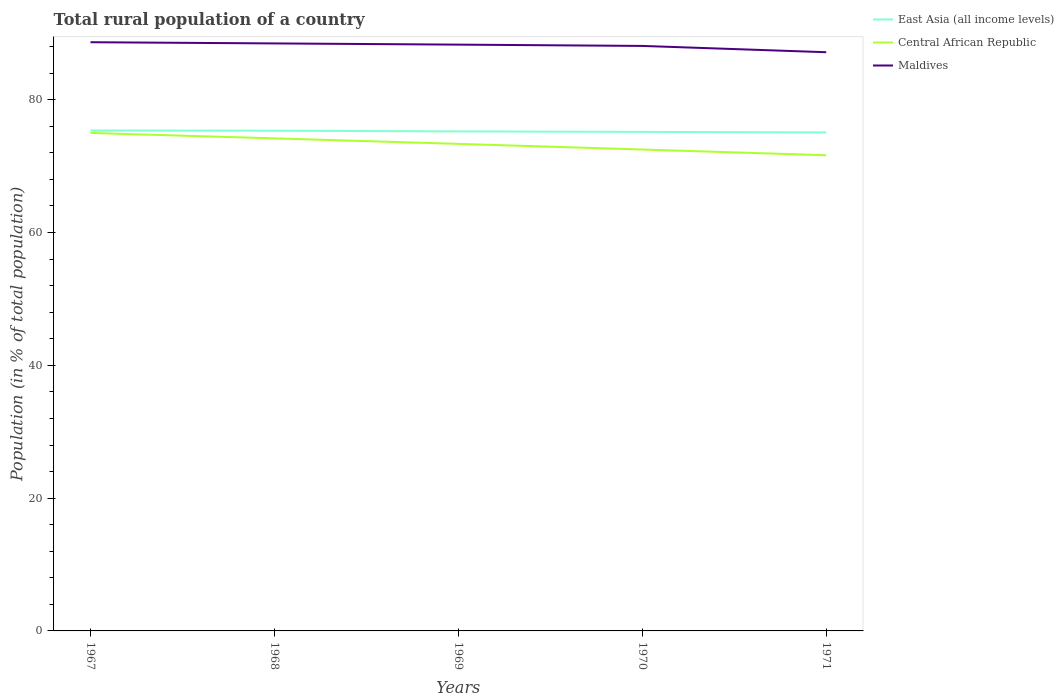How many different coloured lines are there?
Provide a short and direct response. 3. Does the line corresponding to Central African Republic intersect with the line corresponding to East Asia (all income levels)?
Your response must be concise. No. Is the number of lines equal to the number of legend labels?
Your answer should be very brief. Yes. Across all years, what is the maximum rural population in Maldives?
Give a very brief answer. 87.16. In which year was the rural population in Maldives maximum?
Provide a short and direct response. 1971. What is the total rural population in Maldives in the graph?
Keep it short and to the point. 1.51. What is the difference between the highest and the second highest rural population in Maldives?
Your answer should be very brief. 1.51. Is the rural population in East Asia (all income levels) strictly greater than the rural population in Maldives over the years?
Your response must be concise. Yes. How many years are there in the graph?
Keep it short and to the point. 5. What is the difference between two consecutive major ticks on the Y-axis?
Give a very brief answer. 20. Are the values on the major ticks of Y-axis written in scientific E-notation?
Offer a terse response. No. Does the graph contain grids?
Keep it short and to the point. No. What is the title of the graph?
Your response must be concise. Total rural population of a country. Does "Cabo Verde" appear as one of the legend labels in the graph?
Your answer should be compact. No. What is the label or title of the X-axis?
Offer a terse response. Years. What is the label or title of the Y-axis?
Make the answer very short. Population (in % of total population). What is the Population (in % of total population) in East Asia (all income levels) in 1967?
Give a very brief answer. 75.37. What is the Population (in % of total population) in Maldives in 1967?
Your answer should be very brief. 88.66. What is the Population (in % of total population) in East Asia (all income levels) in 1968?
Provide a short and direct response. 75.34. What is the Population (in % of total population) in Central African Republic in 1968?
Your answer should be compact. 74.19. What is the Population (in % of total population) in Maldives in 1968?
Provide a succinct answer. 88.48. What is the Population (in % of total population) in East Asia (all income levels) in 1969?
Give a very brief answer. 75.23. What is the Population (in % of total population) in Central African Republic in 1969?
Your answer should be very brief. 73.36. What is the Population (in % of total population) of Maldives in 1969?
Your answer should be very brief. 88.3. What is the Population (in % of total population) in East Asia (all income levels) in 1970?
Offer a very short reply. 75.16. What is the Population (in % of total population) in Central African Republic in 1970?
Provide a succinct answer. 72.51. What is the Population (in % of total population) of Maldives in 1970?
Provide a succinct answer. 88.11. What is the Population (in % of total population) of East Asia (all income levels) in 1971?
Offer a very short reply. 75.08. What is the Population (in % of total population) in Central African Republic in 1971?
Keep it short and to the point. 71.64. What is the Population (in % of total population) of Maldives in 1971?
Offer a very short reply. 87.16. Across all years, what is the maximum Population (in % of total population) in East Asia (all income levels)?
Give a very brief answer. 75.37. Across all years, what is the maximum Population (in % of total population) of Maldives?
Provide a short and direct response. 88.66. Across all years, what is the minimum Population (in % of total population) in East Asia (all income levels)?
Give a very brief answer. 75.08. Across all years, what is the minimum Population (in % of total population) in Central African Republic?
Give a very brief answer. 71.64. Across all years, what is the minimum Population (in % of total population) in Maldives?
Your answer should be compact. 87.16. What is the total Population (in % of total population) in East Asia (all income levels) in the graph?
Your answer should be compact. 376.18. What is the total Population (in % of total population) in Central African Republic in the graph?
Provide a short and direct response. 366.69. What is the total Population (in % of total population) in Maldives in the graph?
Provide a succinct answer. 440.71. What is the difference between the Population (in % of total population) in East Asia (all income levels) in 1967 and that in 1968?
Provide a succinct answer. 0.04. What is the difference between the Population (in % of total population) in Central African Republic in 1967 and that in 1968?
Your answer should be very brief. 0.81. What is the difference between the Population (in % of total population) in Maldives in 1967 and that in 1968?
Keep it short and to the point. 0.18. What is the difference between the Population (in % of total population) in East Asia (all income levels) in 1967 and that in 1969?
Keep it short and to the point. 0.14. What is the difference between the Population (in % of total population) in Central African Republic in 1967 and that in 1969?
Give a very brief answer. 1.65. What is the difference between the Population (in % of total population) in Maldives in 1967 and that in 1969?
Provide a succinct answer. 0.36. What is the difference between the Population (in % of total population) of East Asia (all income levels) in 1967 and that in 1970?
Provide a short and direct response. 0.21. What is the difference between the Population (in % of total population) of Central African Republic in 1967 and that in 1970?
Your answer should be compact. 2.49. What is the difference between the Population (in % of total population) in Maldives in 1967 and that in 1970?
Your response must be concise. 0.56. What is the difference between the Population (in % of total population) of East Asia (all income levels) in 1967 and that in 1971?
Offer a very short reply. 0.29. What is the difference between the Population (in % of total population) of Central African Republic in 1967 and that in 1971?
Give a very brief answer. 3.36. What is the difference between the Population (in % of total population) in Maldives in 1967 and that in 1971?
Offer a terse response. 1.51. What is the difference between the Population (in % of total population) of East Asia (all income levels) in 1968 and that in 1969?
Ensure brevity in your answer.  0.1. What is the difference between the Population (in % of total population) of Central African Republic in 1968 and that in 1969?
Give a very brief answer. 0.83. What is the difference between the Population (in % of total population) in Maldives in 1968 and that in 1969?
Offer a very short reply. 0.18. What is the difference between the Population (in % of total population) of East Asia (all income levels) in 1968 and that in 1970?
Make the answer very short. 0.18. What is the difference between the Population (in % of total population) of Central African Republic in 1968 and that in 1970?
Keep it short and to the point. 1.68. What is the difference between the Population (in % of total population) of Maldives in 1968 and that in 1970?
Your answer should be very brief. 0.38. What is the difference between the Population (in % of total population) in East Asia (all income levels) in 1968 and that in 1971?
Make the answer very short. 0.26. What is the difference between the Population (in % of total population) of Central African Republic in 1968 and that in 1971?
Ensure brevity in your answer.  2.54. What is the difference between the Population (in % of total population) of Maldives in 1968 and that in 1971?
Give a very brief answer. 1.33. What is the difference between the Population (in % of total population) in East Asia (all income levels) in 1969 and that in 1970?
Your answer should be very brief. 0.07. What is the difference between the Population (in % of total population) of Central African Republic in 1969 and that in 1970?
Offer a terse response. 0.85. What is the difference between the Population (in % of total population) in Maldives in 1969 and that in 1970?
Give a very brief answer. 0.2. What is the difference between the Population (in % of total population) of East Asia (all income levels) in 1969 and that in 1971?
Give a very brief answer. 0.15. What is the difference between the Population (in % of total population) in Central African Republic in 1969 and that in 1971?
Your response must be concise. 1.71. What is the difference between the Population (in % of total population) in Maldives in 1969 and that in 1971?
Make the answer very short. 1.14. What is the difference between the Population (in % of total population) of East Asia (all income levels) in 1970 and that in 1971?
Your response must be concise. 0.08. What is the difference between the Population (in % of total population) in Central African Republic in 1970 and that in 1971?
Give a very brief answer. 0.86. What is the difference between the Population (in % of total population) in Maldives in 1970 and that in 1971?
Your response must be concise. 0.95. What is the difference between the Population (in % of total population) in East Asia (all income levels) in 1967 and the Population (in % of total population) in Central African Republic in 1968?
Your answer should be compact. 1.19. What is the difference between the Population (in % of total population) in East Asia (all income levels) in 1967 and the Population (in % of total population) in Maldives in 1968?
Keep it short and to the point. -13.11. What is the difference between the Population (in % of total population) of Central African Republic in 1967 and the Population (in % of total population) of Maldives in 1968?
Provide a short and direct response. -13.48. What is the difference between the Population (in % of total population) of East Asia (all income levels) in 1967 and the Population (in % of total population) of Central African Republic in 1969?
Provide a short and direct response. 2.02. What is the difference between the Population (in % of total population) in East Asia (all income levels) in 1967 and the Population (in % of total population) in Maldives in 1969?
Ensure brevity in your answer.  -12.93. What is the difference between the Population (in % of total population) of Central African Republic in 1967 and the Population (in % of total population) of Maldives in 1969?
Your answer should be very brief. -13.3. What is the difference between the Population (in % of total population) in East Asia (all income levels) in 1967 and the Population (in % of total population) in Central African Republic in 1970?
Give a very brief answer. 2.87. What is the difference between the Population (in % of total population) in East Asia (all income levels) in 1967 and the Population (in % of total population) in Maldives in 1970?
Keep it short and to the point. -12.73. What is the difference between the Population (in % of total population) in Central African Republic in 1967 and the Population (in % of total population) in Maldives in 1970?
Offer a very short reply. -13.11. What is the difference between the Population (in % of total population) in East Asia (all income levels) in 1967 and the Population (in % of total population) in Central African Republic in 1971?
Your answer should be very brief. 3.73. What is the difference between the Population (in % of total population) in East Asia (all income levels) in 1967 and the Population (in % of total population) in Maldives in 1971?
Your answer should be compact. -11.78. What is the difference between the Population (in % of total population) of Central African Republic in 1967 and the Population (in % of total population) of Maldives in 1971?
Give a very brief answer. -12.16. What is the difference between the Population (in % of total population) in East Asia (all income levels) in 1968 and the Population (in % of total population) in Central African Republic in 1969?
Your answer should be compact. 1.98. What is the difference between the Population (in % of total population) of East Asia (all income levels) in 1968 and the Population (in % of total population) of Maldives in 1969?
Your answer should be very brief. -12.96. What is the difference between the Population (in % of total population) in Central African Republic in 1968 and the Population (in % of total population) in Maldives in 1969?
Your response must be concise. -14.12. What is the difference between the Population (in % of total population) in East Asia (all income levels) in 1968 and the Population (in % of total population) in Central African Republic in 1970?
Offer a terse response. 2.83. What is the difference between the Population (in % of total population) of East Asia (all income levels) in 1968 and the Population (in % of total population) of Maldives in 1970?
Provide a short and direct response. -12.77. What is the difference between the Population (in % of total population) of Central African Republic in 1968 and the Population (in % of total population) of Maldives in 1970?
Your response must be concise. -13.92. What is the difference between the Population (in % of total population) in East Asia (all income levels) in 1968 and the Population (in % of total population) in Central African Republic in 1971?
Ensure brevity in your answer.  3.69. What is the difference between the Population (in % of total population) in East Asia (all income levels) in 1968 and the Population (in % of total population) in Maldives in 1971?
Keep it short and to the point. -11.82. What is the difference between the Population (in % of total population) in Central African Republic in 1968 and the Population (in % of total population) in Maldives in 1971?
Keep it short and to the point. -12.97. What is the difference between the Population (in % of total population) in East Asia (all income levels) in 1969 and the Population (in % of total population) in Central African Republic in 1970?
Your answer should be compact. 2.72. What is the difference between the Population (in % of total population) of East Asia (all income levels) in 1969 and the Population (in % of total population) of Maldives in 1970?
Your answer should be compact. -12.87. What is the difference between the Population (in % of total population) of Central African Republic in 1969 and the Population (in % of total population) of Maldives in 1970?
Give a very brief answer. -14.75. What is the difference between the Population (in % of total population) of East Asia (all income levels) in 1969 and the Population (in % of total population) of Central African Republic in 1971?
Offer a very short reply. 3.59. What is the difference between the Population (in % of total population) in East Asia (all income levels) in 1969 and the Population (in % of total population) in Maldives in 1971?
Provide a succinct answer. -11.93. What is the difference between the Population (in % of total population) in Central African Republic in 1969 and the Population (in % of total population) in Maldives in 1971?
Ensure brevity in your answer.  -13.8. What is the difference between the Population (in % of total population) in East Asia (all income levels) in 1970 and the Population (in % of total population) in Central African Republic in 1971?
Make the answer very short. 3.52. What is the difference between the Population (in % of total population) in East Asia (all income levels) in 1970 and the Population (in % of total population) in Maldives in 1971?
Provide a short and direct response. -12. What is the difference between the Population (in % of total population) in Central African Republic in 1970 and the Population (in % of total population) in Maldives in 1971?
Provide a short and direct response. -14.65. What is the average Population (in % of total population) of East Asia (all income levels) per year?
Offer a terse response. 75.24. What is the average Population (in % of total population) of Central African Republic per year?
Your answer should be compact. 73.34. What is the average Population (in % of total population) of Maldives per year?
Offer a very short reply. 88.14. In the year 1967, what is the difference between the Population (in % of total population) of East Asia (all income levels) and Population (in % of total population) of Central African Republic?
Your answer should be compact. 0.37. In the year 1967, what is the difference between the Population (in % of total population) in East Asia (all income levels) and Population (in % of total population) in Maldives?
Your answer should be very brief. -13.29. In the year 1967, what is the difference between the Population (in % of total population) in Central African Republic and Population (in % of total population) in Maldives?
Offer a very short reply. -13.66. In the year 1968, what is the difference between the Population (in % of total population) in East Asia (all income levels) and Population (in % of total population) in Central African Republic?
Ensure brevity in your answer.  1.15. In the year 1968, what is the difference between the Population (in % of total population) in East Asia (all income levels) and Population (in % of total population) in Maldives?
Your answer should be compact. -13.15. In the year 1968, what is the difference between the Population (in % of total population) in Central African Republic and Population (in % of total population) in Maldives?
Provide a succinct answer. -14.3. In the year 1969, what is the difference between the Population (in % of total population) of East Asia (all income levels) and Population (in % of total population) of Central African Republic?
Ensure brevity in your answer.  1.88. In the year 1969, what is the difference between the Population (in % of total population) in East Asia (all income levels) and Population (in % of total population) in Maldives?
Provide a succinct answer. -13.07. In the year 1969, what is the difference between the Population (in % of total population) of Central African Republic and Population (in % of total population) of Maldives?
Ensure brevity in your answer.  -14.95. In the year 1970, what is the difference between the Population (in % of total population) in East Asia (all income levels) and Population (in % of total population) in Central African Republic?
Keep it short and to the point. 2.65. In the year 1970, what is the difference between the Population (in % of total population) of East Asia (all income levels) and Population (in % of total population) of Maldives?
Provide a succinct answer. -12.95. In the year 1970, what is the difference between the Population (in % of total population) in Central African Republic and Population (in % of total population) in Maldives?
Keep it short and to the point. -15.6. In the year 1971, what is the difference between the Population (in % of total population) in East Asia (all income levels) and Population (in % of total population) in Central African Republic?
Make the answer very short. 3.43. In the year 1971, what is the difference between the Population (in % of total population) of East Asia (all income levels) and Population (in % of total population) of Maldives?
Ensure brevity in your answer.  -12.08. In the year 1971, what is the difference between the Population (in % of total population) of Central African Republic and Population (in % of total population) of Maldives?
Your response must be concise. -15.51. What is the ratio of the Population (in % of total population) in East Asia (all income levels) in 1967 to that in 1968?
Ensure brevity in your answer.  1. What is the ratio of the Population (in % of total population) of Central African Republic in 1967 to that in 1969?
Offer a very short reply. 1.02. What is the ratio of the Population (in % of total population) in Maldives in 1967 to that in 1969?
Keep it short and to the point. 1. What is the ratio of the Population (in % of total population) of Central African Republic in 1967 to that in 1970?
Offer a terse response. 1.03. What is the ratio of the Population (in % of total population) in Maldives in 1967 to that in 1970?
Provide a succinct answer. 1.01. What is the ratio of the Population (in % of total population) in East Asia (all income levels) in 1967 to that in 1971?
Make the answer very short. 1. What is the ratio of the Population (in % of total population) in Central African Republic in 1967 to that in 1971?
Provide a short and direct response. 1.05. What is the ratio of the Population (in % of total population) in Maldives in 1967 to that in 1971?
Provide a short and direct response. 1.02. What is the ratio of the Population (in % of total population) of East Asia (all income levels) in 1968 to that in 1969?
Offer a very short reply. 1. What is the ratio of the Population (in % of total population) in Central African Republic in 1968 to that in 1969?
Provide a succinct answer. 1.01. What is the ratio of the Population (in % of total population) of Maldives in 1968 to that in 1969?
Offer a very short reply. 1. What is the ratio of the Population (in % of total population) in Central African Republic in 1968 to that in 1970?
Offer a terse response. 1.02. What is the ratio of the Population (in % of total population) of Maldives in 1968 to that in 1970?
Ensure brevity in your answer.  1. What is the ratio of the Population (in % of total population) in East Asia (all income levels) in 1968 to that in 1971?
Provide a short and direct response. 1. What is the ratio of the Population (in % of total population) of Central African Republic in 1968 to that in 1971?
Give a very brief answer. 1.04. What is the ratio of the Population (in % of total population) in Maldives in 1968 to that in 1971?
Offer a terse response. 1.02. What is the ratio of the Population (in % of total population) in East Asia (all income levels) in 1969 to that in 1970?
Your response must be concise. 1. What is the ratio of the Population (in % of total population) of Central African Republic in 1969 to that in 1970?
Give a very brief answer. 1.01. What is the ratio of the Population (in % of total population) in Maldives in 1969 to that in 1970?
Your answer should be very brief. 1. What is the ratio of the Population (in % of total population) in Central African Republic in 1969 to that in 1971?
Your answer should be very brief. 1.02. What is the ratio of the Population (in % of total population) in Maldives in 1969 to that in 1971?
Give a very brief answer. 1.01. What is the ratio of the Population (in % of total population) of Central African Republic in 1970 to that in 1971?
Ensure brevity in your answer.  1.01. What is the ratio of the Population (in % of total population) in Maldives in 1970 to that in 1971?
Your answer should be compact. 1.01. What is the difference between the highest and the second highest Population (in % of total population) of East Asia (all income levels)?
Keep it short and to the point. 0.04. What is the difference between the highest and the second highest Population (in % of total population) of Central African Republic?
Offer a very short reply. 0.81. What is the difference between the highest and the second highest Population (in % of total population) of Maldives?
Ensure brevity in your answer.  0.18. What is the difference between the highest and the lowest Population (in % of total population) in East Asia (all income levels)?
Your response must be concise. 0.29. What is the difference between the highest and the lowest Population (in % of total population) of Central African Republic?
Give a very brief answer. 3.36. What is the difference between the highest and the lowest Population (in % of total population) of Maldives?
Your answer should be compact. 1.51. 